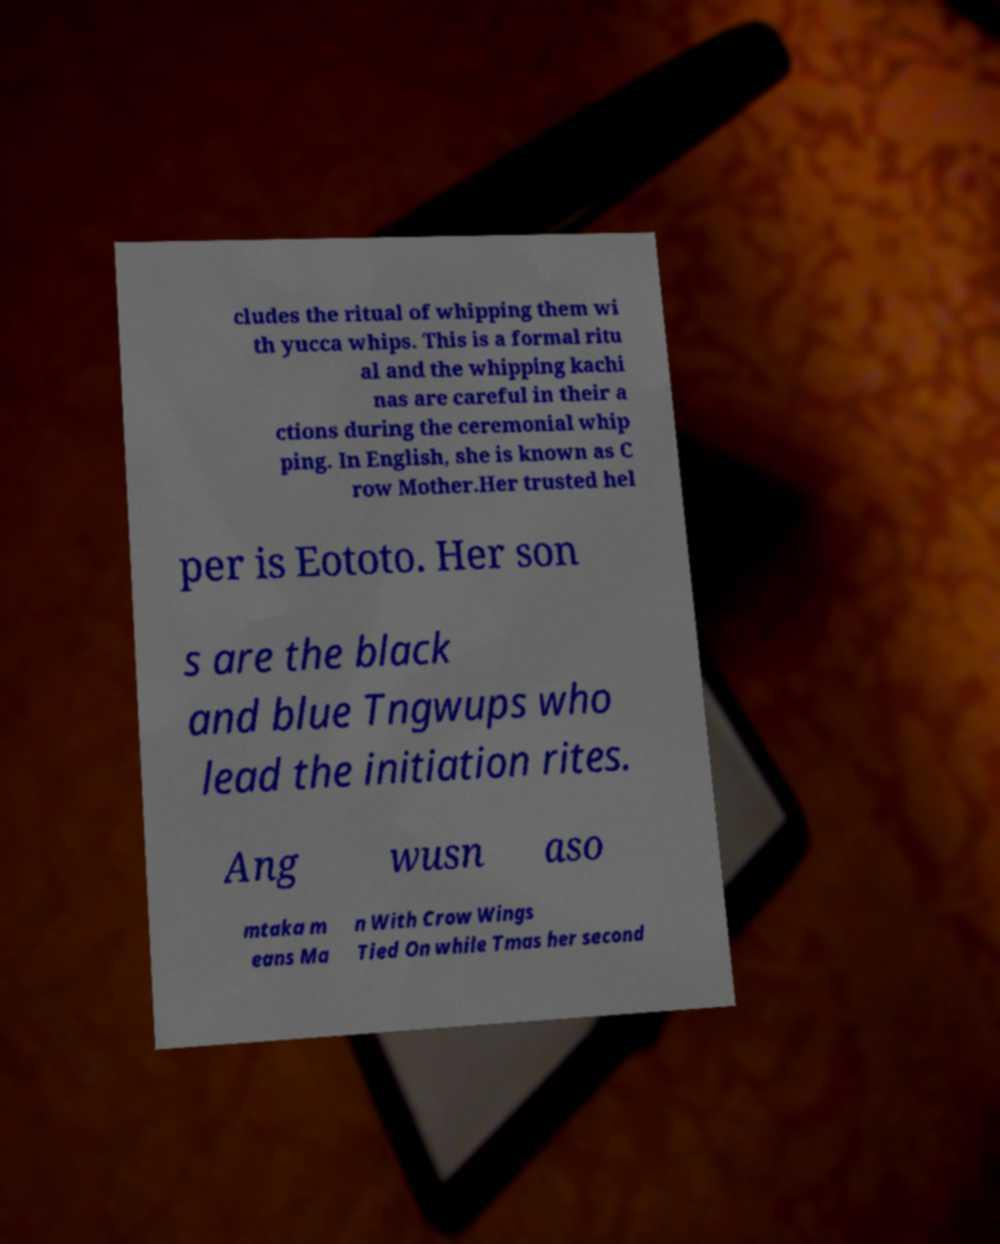I need the written content from this picture converted into text. Can you do that? cludes the ritual of whipping them wi th yucca whips. This is a formal ritu al and the whipping kachi nas are careful in their a ctions during the ceremonial whip ping. In English, she is known as C row Mother.Her trusted hel per is Eototo. Her son s are the black and blue Tngwups who lead the initiation rites. Ang wusn aso mtaka m eans Ma n With Crow Wings Tied On while Tmas her second 